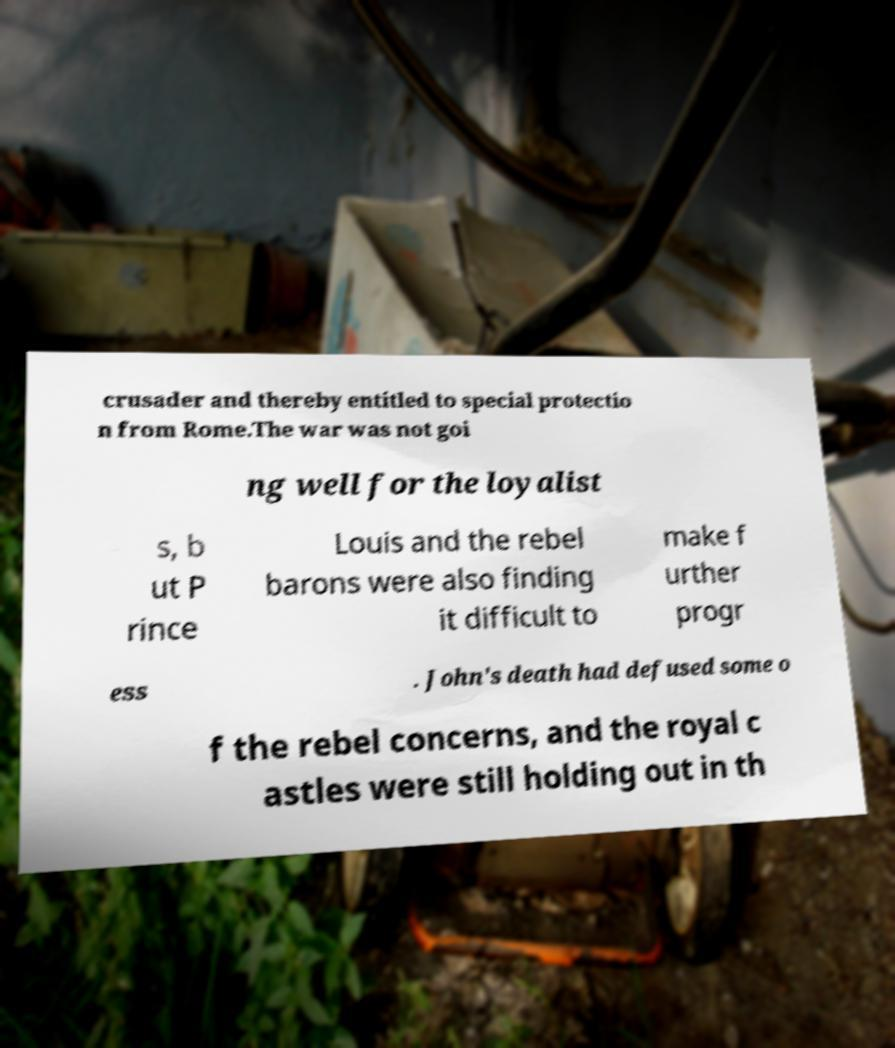I need the written content from this picture converted into text. Can you do that? crusader and thereby entitled to special protectio n from Rome.The war was not goi ng well for the loyalist s, b ut P rince Louis and the rebel barons were also finding it difficult to make f urther progr ess . John's death had defused some o f the rebel concerns, and the royal c astles were still holding out in th 